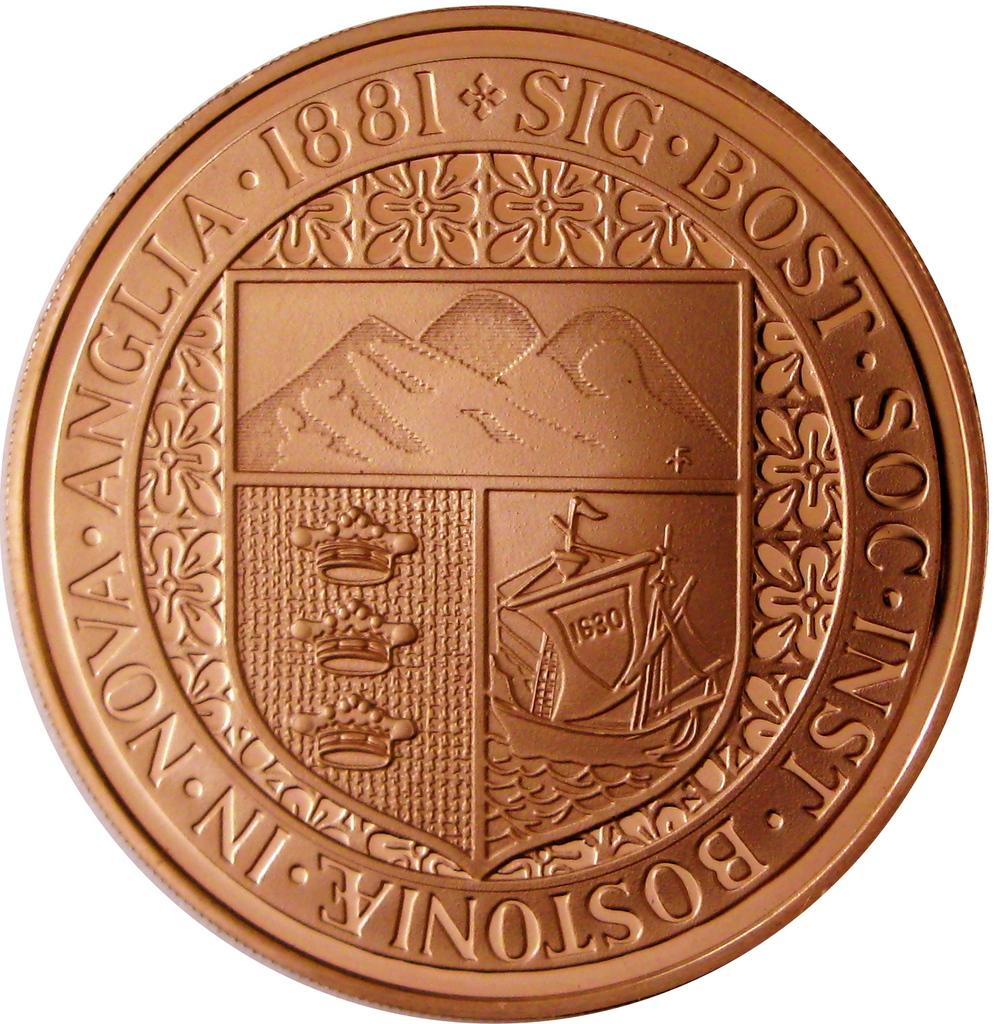Provide a one-sentence caption for the provided image. A foreign coin has the year 1881 printed on it. 